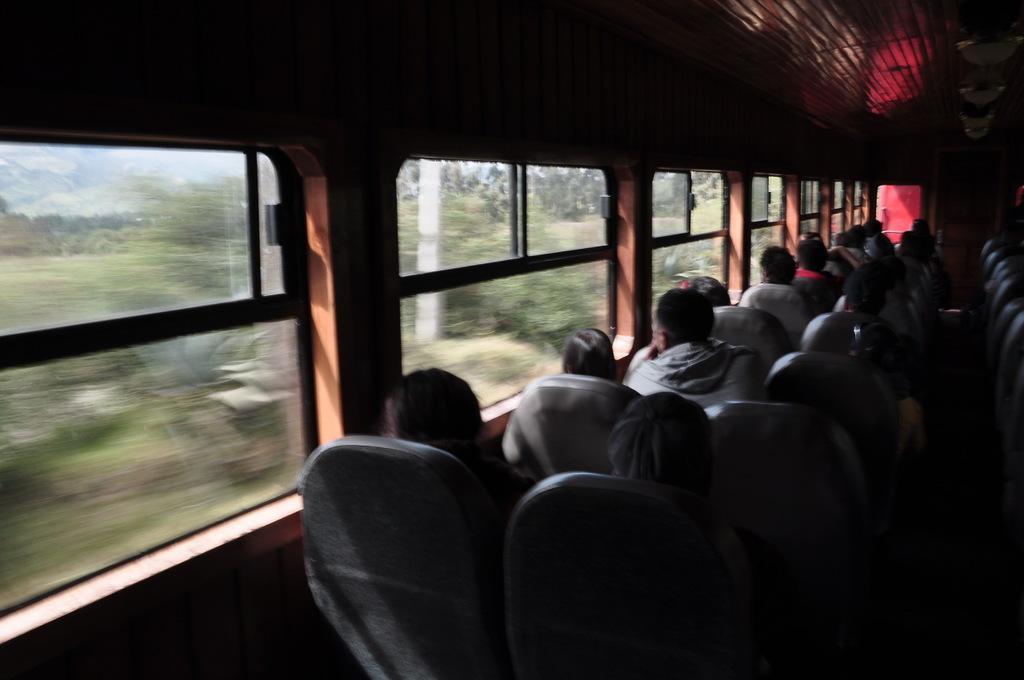In one or two sentences, can you explain what this image depicts? This image consists of a train in which there are many people sitting. On the left, there are windows. At the top, there is a luggage rack. In the front, we can see many seats. 